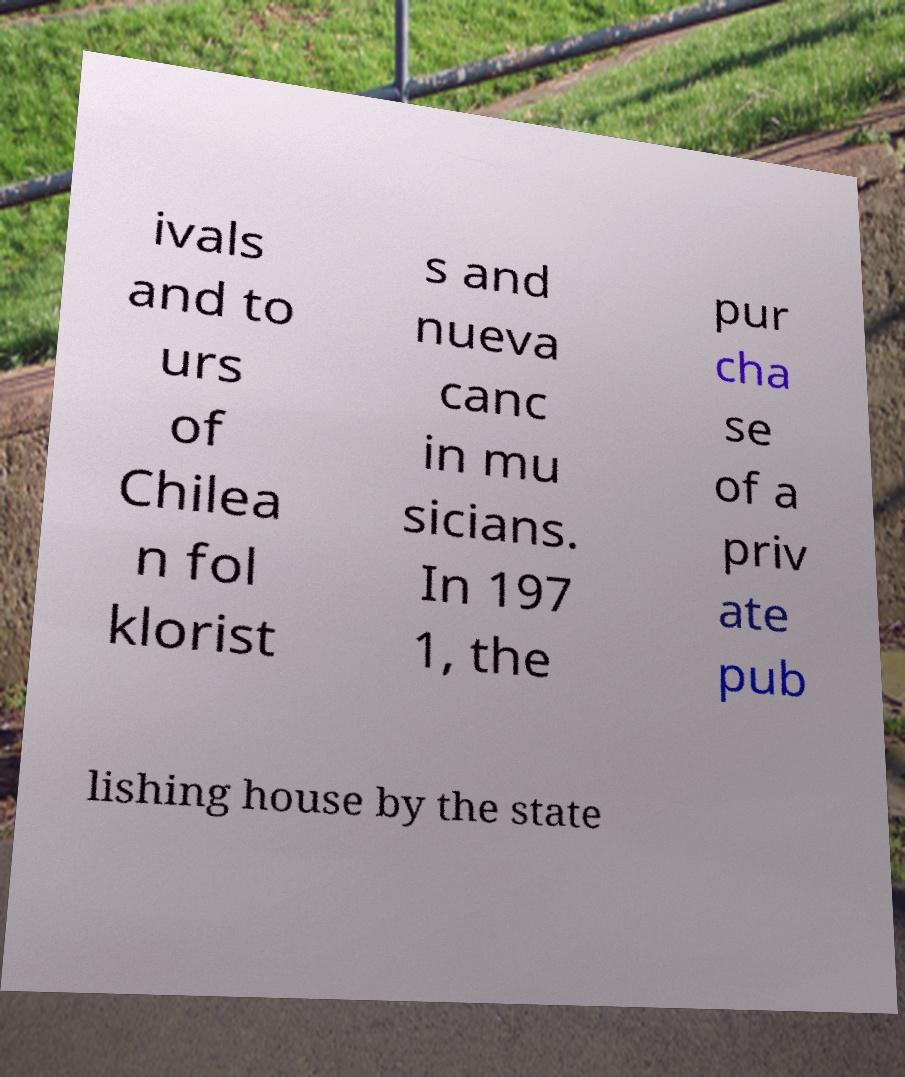For documentation purposes, I need the text within this image transcribed. Could you provide that? ivals and to urs of Chilea n fol klorist s and nueva canc in mu sicians. In 197 1, the pur cha se of a priv ate pub lishing house by the state 